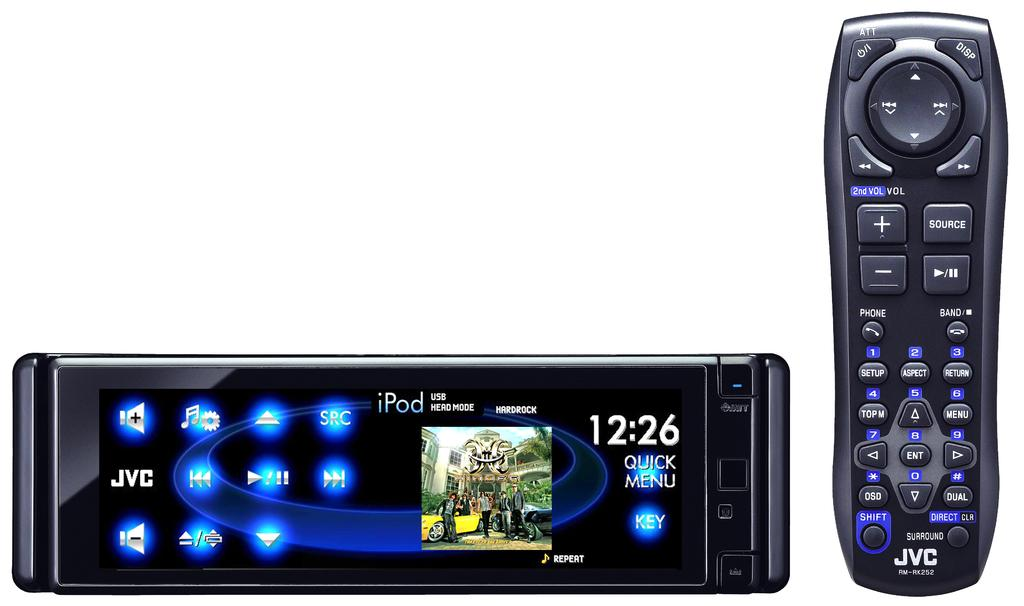<image>
Offer a succinct explanation of the picture presented. A JVC remote sits next to a JVC stereo system. 